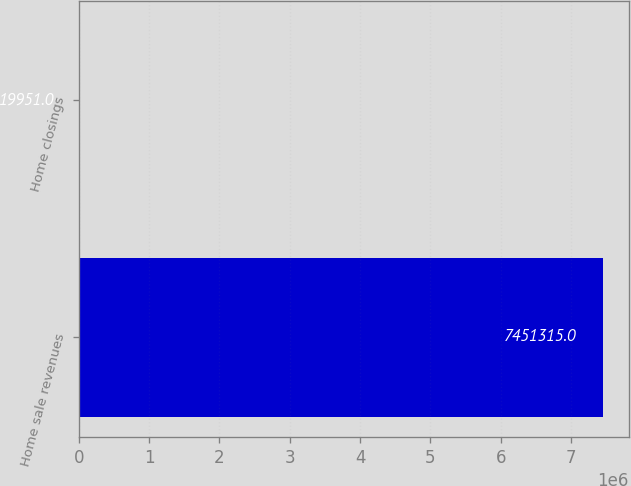Convert chart to OTSL. <chart><loc_0><loc_0><loc_500><loc_500><bar_chart><fcel>Home sale revenues<fcel>Home closings<nl><fcel>7.45132e+06<fcel>19951<nl></chart> 